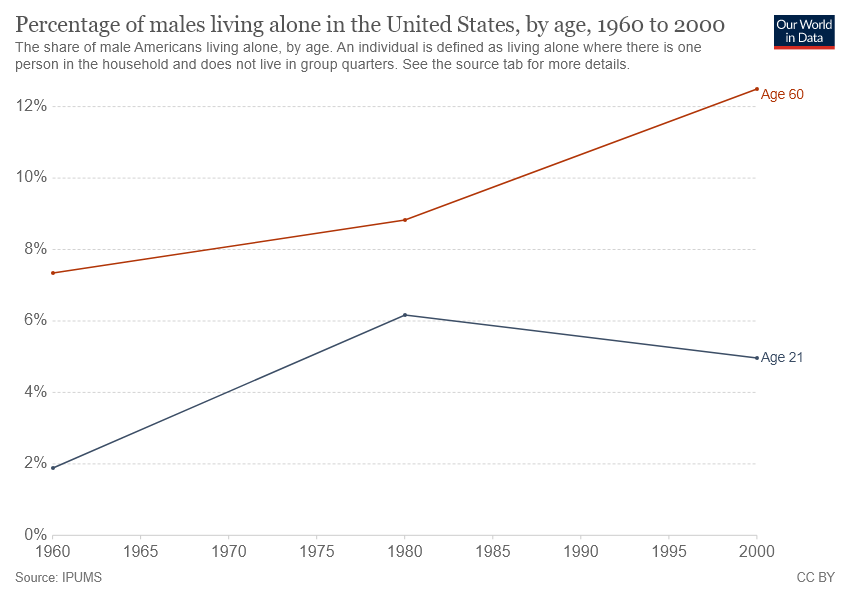Draw attention to some important aspects in this diagram. The median value of the red graph was in 1980. 